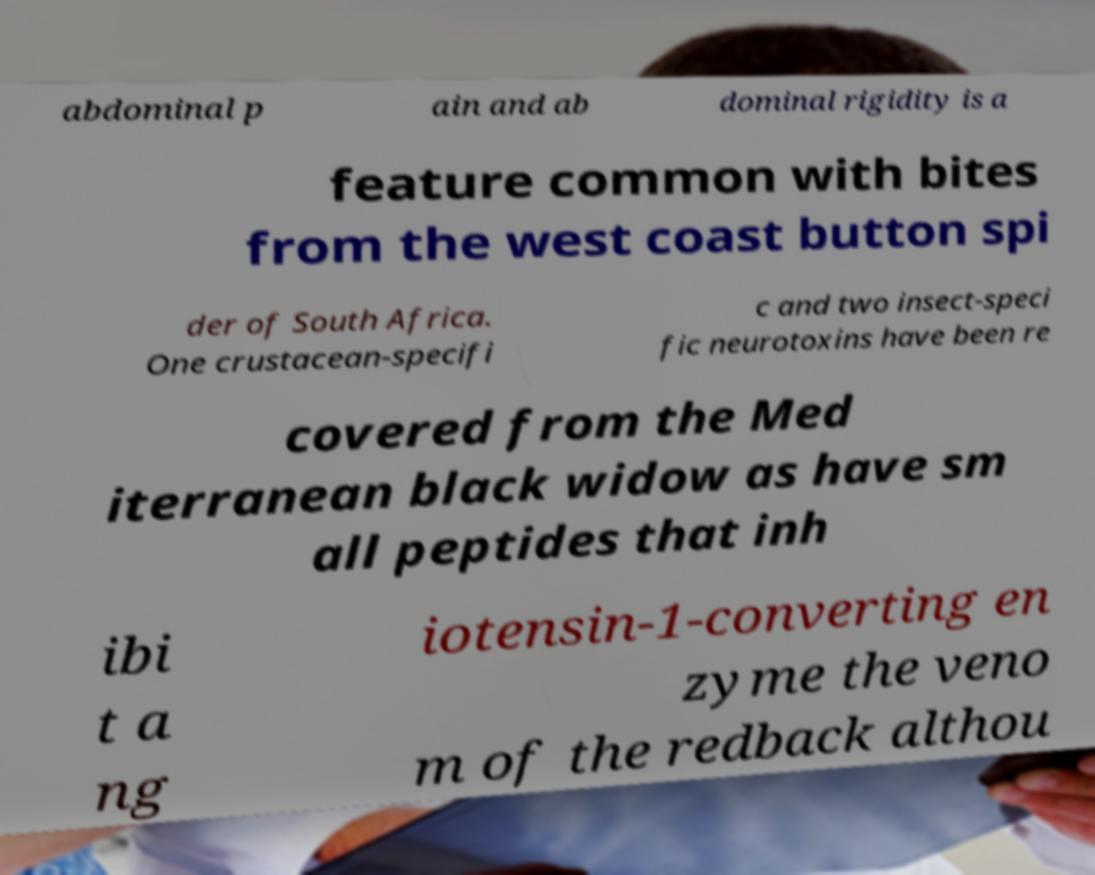Please identify and transcribe the text found in this image. abdominal p ain and ab dominal rigidity is a feature common with bites from the west coast button spi der of South Africa. One crustacean-specifi c and two insect-speci fic neurotoxins have been re covered from the Med iterranean black widow as have sm all peptides that inh ibi t a ng iotensin-1-converting en zyme the veno m of the redback althou 